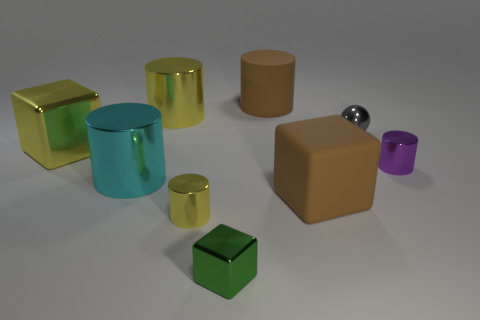Are there any tiny gray shiny spheres on the left side of the rubber cylinder?
Offer a terse response. No. There is a small thing that is in front of the small yellow cylinder; does it have the same shape as the big cyan shiny thing?
Offer a very short reply. No. There is a large object that is the same color as the matte block; what is its material?
Ensure brevity in your answer.  Rubber. How many metal cylinders are the same color as the small metallic sphere?
Give a very brief answer. 0. What is the shape of the metallic object in front of the small metal cylinder on the left side of the rubber cylinder?
Offer a terse response. Cube. Are there any gray objects of the same shape as the green thing?
Keep it short and to the point. No. Does the small metal sphere have the same color as the small metal cylinder that is in front of the tiny purple shiny thing?
Your answer should be very brief. No. There is a thing that is the same color as the big rubber block; what size is it?
Your answer should be very brief. Large. Is there a cyan shiny cylinder of the same size as the ball?
Provide a succinct answer. No. Is the cyan cylinder made of the same material as the tiny cylinder left of the tiny metallic block?
Ensure brevity in your answer.  Yes. 